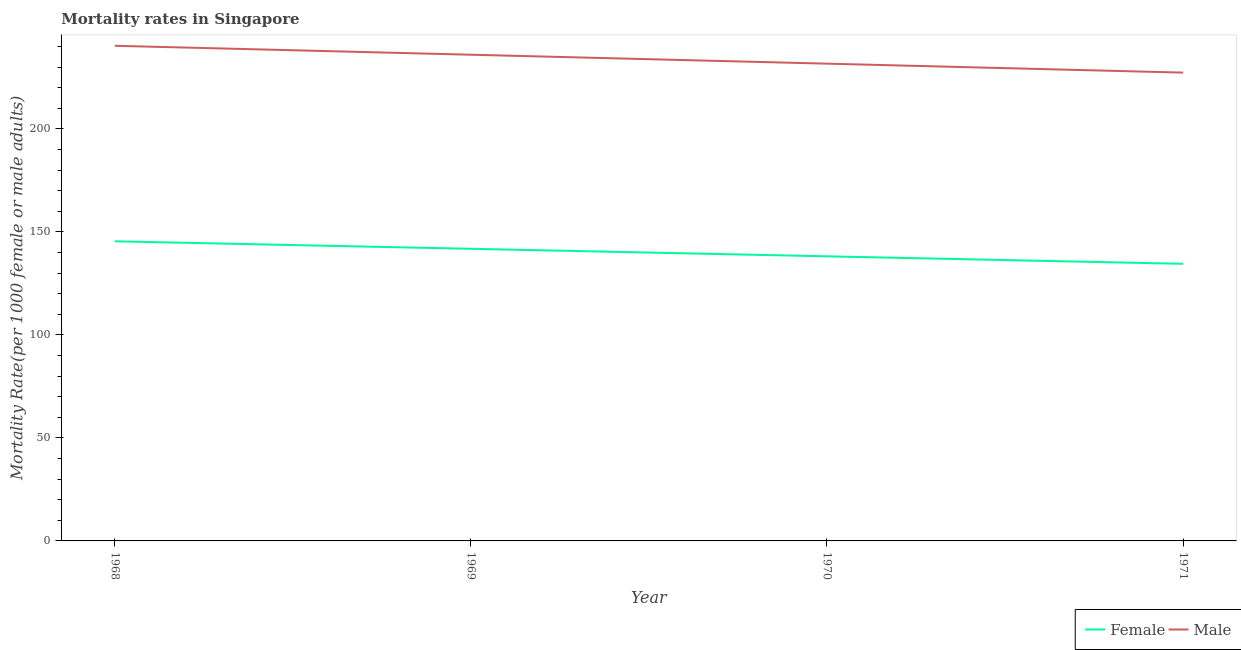Is the number of lines equal to the number of legend labels?
Provide a short and direct response. Yes. What is the female mortality rate in 1968?
Make the answer very short. 145.44. Across all years, what is the maximum male mortality rate?
Offer a terse response. 240.35. Across all years, what is the minimum female mortality rate?
Make the answer very short. 134.51. In which year was the male mortality rate maximum?
Give a very brief answer. 1968. In which year was the female mortality rate minimum?
Your answer should be compact. 1971. What is the total male mortality rate in the graph?
Your answer should be very brief. 935.34. What is the difference between the female mortality rate in 1970 and that in 1971?
Ensure brevity in your answer.  3.64. What is the difference between the male mortality rate in 1971 and the female mortality rate in 1970?
Offer a very short reply. 89.17. What is the average female mortality rate per year?
Provide a short and direct response. 139.98. In the year 1968, what is the difference between the female mortality rate and male mortality rate?
Offer a terse response. -94.91. What is the ratio of the male mortality rate in 1968 to that in 1970?
Offer a terse response. 1.04. Is the female mortality rate in 1968 less than that in 1971?
Your answer should be very brief. No. What is the difference between the highest and the second highest male mortality rate?
Provide a succinct answer. 4.34. What is the difference between the highest and the lowest female mortality rate?
Your answer should be very brief. 10.93. In how many years, is the female mortality rate greater than the average female mortality rate taken over all years?
Give a very brief answer. 2. Is the female mortality rate strictly greater than the male mortality rate over the years?
Ensure brevity in your answer.  No. How many years are there in the graph?
Give a very brief answer. 4. What is the difference between two consecutive major ticks on the Y-axis?
Make the answer very short. 50. Are the values on the major ticks of Y-axis written in scientific E-notation?
Keep it short and to the point. No. Does the graph contain any zero values?
Your response must be concise. No. Does the graph contain grids?
Give a very brief answer. No. Where does the legend appear in the graph?
Ensure brevity in your answer.  Bottom right. How many legend labels are there?
Your response must be concise. 2. What is the title of the graph?
Your answer should be very brief. Mortality rates in Singapore. What is the label or title of the X-axis?
Provide a succinct answer. Year. What is the label or title of the Y-axis?
Make the answer very short. Mortality Rate(per 1000 female or male adults). What is the Mortality Rate(per 1000 female or male adults) of Female in 1968?
Your answer should be compact. 145.44. What is the Mortality Rate(per 1000 female or male adults) in Male in 1968?
Provide a succinct answer. 240.35. What is the Mortality Rate(per 1000 female or male adults) in Female in 1969?
Provide a short and direct response. 141.8. What is the Mortality Rate(per 1000 female or male adults) of Male in 1969?
Your answer should be compact. 236. What is the Mortality Rate(per 1000 female or male adults) of Female in 1970?
Provide a succinct answer. 138.15. What is the Mortality Rate(per 1000 female or male adults) of Male in 1970?
Make the answer very short. 231.66. What is the Mortality Rate(per 1000 female or male adults) in Female in 1971?
Offer a terse response. 134.51. What is the Mortality Rate(per 1000 female or male adults) of Male in 1971?
Offer a very short reply. 227.32. Across all years, what is the maximum Mortality Rate(per 1000 female or male adults) in Female?
Offer a very short reply. 145.44. Across all years, what is the maximum Mortality Rate(per 1000 female or male adults) of Male?
Your response must be concise. 240.35. Across all years, what is the minimum Mortality Rate(per 1000 female or male adults) of Female?
Your response must be concise. 134.51. Across all years, what is the minimum Mortality Rate(per 1000 female or male adults) of Male?
Make the answer very short. 227.32. What is the total Mortality Rate(per 1000 female or male adults) in Female in the graph?
Keep it short and to the point. 559.9. What is the total Mortality Rate(per 1000 female or male adults) of Male in the graph?
Your response must be concise. 935.34. What is the difference between the Mortality Rate(per 1000 female or male adults) in Female in 1968 and that in 1969?
Make the answer very short. 3.64. What is the difference between the Mortality Rate(per 1000 female or male adults) in Male in 1968 and that in 1969?
Offer a very short reply. 4.34. What is the difference between the Mortality Rate(per 1000 female or male adults) of Female in 1968 and that in 1970?
Keep it short and to the point. 7.29. What is the difference between the Mortality Rate(per 1000 female or male adults) of Male in 1968 and that in 1970?
Your answer should be very brief. 8.68. What is the difference between the Mortality Rate(per 1000 female or male adults) of Female in 1968 and that in 1971?
Give a very brief answer. 10.93. What is the difference between the Mortality Rate(per 1000 female or male adults) of Male in 1968 and that in 1971?
Give a very brief answer. 13.02. What is the difference between the Mortality Rate(per 1000 female or male adults) in Female in 1969 and that in 1970?
Your response must be concise. 3.64. What is the difference between the Mortality Rate(per 1000 female or male adults) in Male in 1969 and that in 1970?
Provide a short and direct response. 4.34. What is the difference between the Mortality Rate(per 1000 female or male adults) in Female in 1969 and that in 1971?
Offer a terse response. 7.29. What is the difference between the Mortality Rate(per 1000 female or male adults) in Male in 1969 and that in 1971?
Provide a short and direct response. 8.68. What is the difference between the Mortality Rate(per 1000 female or male adults) in Female in 1970 and that in 1971?
Ensure brevity in your answer.  3.64. What is the difference between the Mortality Rate(per 1000 female or male adults) of Male in 1970 and that in 1971?
Offer a very short reply. 4.34. What is the difference between the Mortality Rate(per 1000 female or male adults) in Female in 1968 and the Mortality Rate(per 1000 female or male adults) in Male in 1969?
Give a very brief answer. -90.56. What is the difference between the Mortality Rate(per 1000 female or male adults) in Female in 1968 and the Mortality Rate(per 1000 female or male adults) in Male in 1970?
Offer a terse response. -86.22. What is the difference between the Mortality Rate(per 1000 female or male adults) in Female in 1968 and the Mortality Rate(per 1000 female or male adults) in Male in 1971?
Your response must be concise. -81.88. What is the difference between the Mortality Rate(per 1000 female or male adults) in Female in 1969 and the Mortality Rate(per 1000 female or male adults) in Male in 1970?
Offer a very short reply. -89.87. What is the difference between the Mortality Rate(per 1000 female or male adults) of Female in 1969 and the Mortality Rate(per 1000 female or male adults) of Male in 1971?
Keep it short and to the point. -85.53. What is the difference between the Mortality Rate(per 1000 female or male adults) of Female in 1970 and the Mortality Rate(per 1000 female or male adults) of Male in 1971?
Your answer should be compact. -89.17. What is the average Mortality Rate(per 1000 female or male adults) of Female per year?
Your answer should be compact. 139.98. What is the average Mortality Rate(per 1000 female or male adults) in Male per year?
Keep it short and to the point. 233.83. In the year 1968, what is the difference between the Mortality Rate(per 1000 female or male adults) of Female and Mortality Rate(per 1000 female or male adults) of Male?
Provide a succinct answer. -94.91. In the year 1969, what is the difference between the Mortality Rate(per 1000 female or male adults) of Female and Mortality Rate(per 1000 female or male adults) of Male?
Your answer should be compact. -94.21. In the year 1970, what is the difference between the Mortality Rate(per 1000 female or male adults) of Female and Mortality Rate(per 1000 female or male adults) of Male?
Offer a very short reply. -93.51. In the year 1971, what is the difference between the Mortality Rate(per 1000 female or male adults) in Female and Mortality Rate(per 1000 female or male adults) in Male?
Your answer should be compact. -92.81. What is the ratio of the Mortality Rate(per 1000 female or male adults) in Female in 1968 to that in 1969?
Provide a short and direct response. 1.03. What is the ratio of the Mortality Rate(per 1000 female or male adults) of Male in 1968 to that in 1969?
Offer a terse response. 1.02. What is the ratio of the Mortality Rate(per 1000 female or male adults) of Female in 1968 to that in 1970?
Ensure brevity in your answer.  1.05. What is the ratio of the Mortality Rate(per 1000 female or male adults) of Male in 1968 to that in 1970?
Give a very brief answer. 1.04. What is the ratio of the Mortality Rate(per 1000 female or male adults) of Female in 1968 to that in 1971?
Your answer should be compact. 1.08. What is the ratio of the Mortality Rate(per 1000 female or male adults) of Male in 1968 to that in 1971?
Your answer should be compact. 1.06. What is the ratio of the Mortality Rate(per 1000 female or male adults) of Female in 1969 to that in 1970?
Ensure brevity in your answer.  1.03. What is the ratio of the Mortality Rate(per 1000 female or male adults) in Male in 1969 to that in 1970?
Provide a succinct answer. 1.02. What is the ratio of the Mortality Rate(per 1000 female or male adults) of Female in 1969 to that in 1971?
Give a very brief answer. 1.05. What is the ratio of the Mortality Rate(per 1000 female or male adults) in Male in 1969 to that in 1971?
Provide a short and direct response. 1.04. What is the ratio of the Mortality Rate(per 1000 female or male adults) of Female in 1970 to that in 1971?
Keep it short and to the point. 1.03. What is the ratio of the Mortality Rate(per 1000 female or male adults) in Male in 1970 to that in 1971?
Keep it short and to the point. 1.02. What is the difference between the highest and the second highest Mortality Rate(per 1000 female or male adults) of Female?
Ensure brevity in your answer.  3.64. What is the difference between the highest and the second highest Mortality Rate(per 1000 female or male adults) of Male?
Keep it short and to the point. 4.34. What is the difference between the highest and the lowest Mortality Rate(per 1000 female or male adults) in Female?
Keep it short and to the point. 10.93. What is the difference between the highest and the lowest Mortality Rate(per 1000 female or male adults) in Male?
Keep it short and to the point. 13.02. 